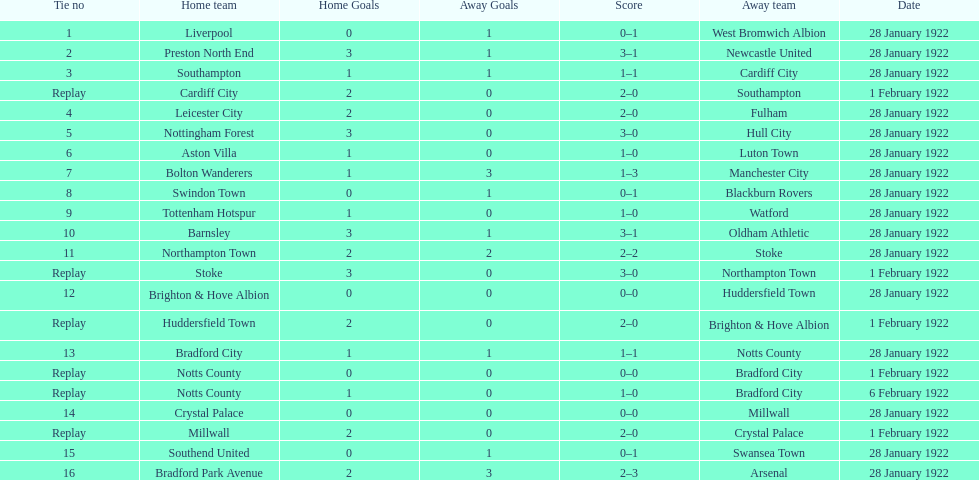How many games had no points scored? 3. 